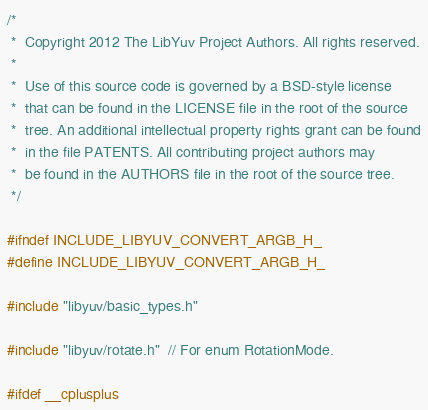<code> <loc_0><loc_0><loc_500><loc_500><_C_>/*
 *  Copyright 2012 The LibYuv Project Authors. All rights reserved.
 *
 *  Use of this source code is governed by a BSD-style license
 *  that can be found in the LICENSE file in the root of the source
 *  tree. An additional intellectual property rights grant can be found
 *  in the file PATENTS. All contributing project authors may
 *  be found in the AUTHORS file in the root of the source tree.
 */

#ifndef INCLUDE_LIBYUV_CONVERT_ARGB_H_
#define INCLUDE_LIBYUV_CONVERT_ARGB_H_

#include "libyuv/basic_types.h"

#include "libyuv/rotate.h"  // For enum RotationMode.

#ifdef __cplusplus</code> 